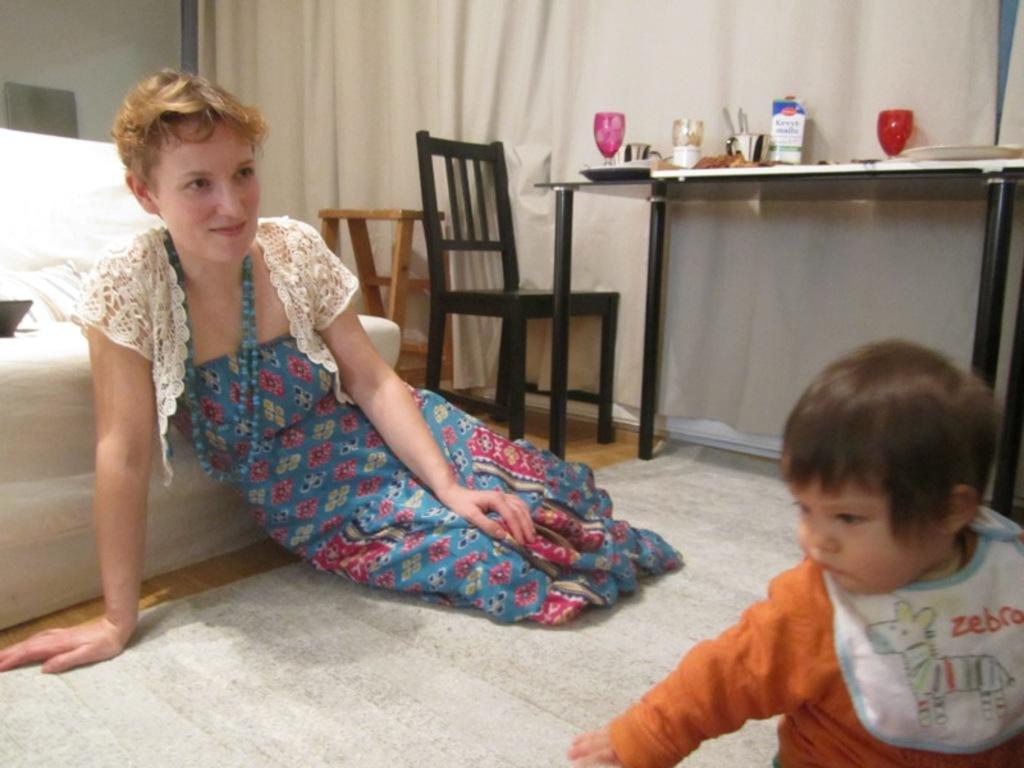<image>
Render a clear and concise summary of the photo. A woman is watching a baby who is wearing a bib that says Zebra. 